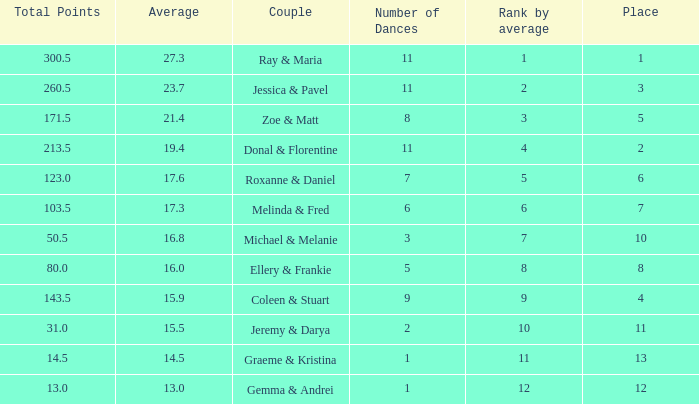Can you give me this table as a dict? {'header': ['Total Points', 'Average', 'Couple', 'Number of Dances', 'Rank by average', 'Place'], 'rows': [['300.5', '27.3', 'Ray & Maria', '11', '1', '1'], ['260.5', '23.7', 'Jessica & Pavel', '11', '2', '3'], ['171.5', '21.4', 'Zoe & Matt', '8', '3', '5'], ['213.5', '19.4', 'Donal & Florentine', '11', '4', '2'], ['123.0', '17.6', 'Roxanne & Daniel', '7', '5', '6'], ['103.5', '17.3', 'Melinda & Fred', '6', '6', '7'], ['50.5', '16.8', 'Michael & Melanie', '3', '7', '10'], ['80.0', '16.0', 'Ellery & Frankie', '5', '8', '8'], ['143.5', '15.9', 'Coleen & Stuart', '9', '9', '4'], ['31.0', '15.5', 'Jeremy & Darya', '2', '10', '11'], ['14.5', '14.5', 'Graeme & Kristina', '1', '11', '13'], ['13.0', '13.0', 'Gemma & Andrei', '1', '12', '12']]} If your rank by average is 9, what is the name of the couple? Coleen & Stuart. 